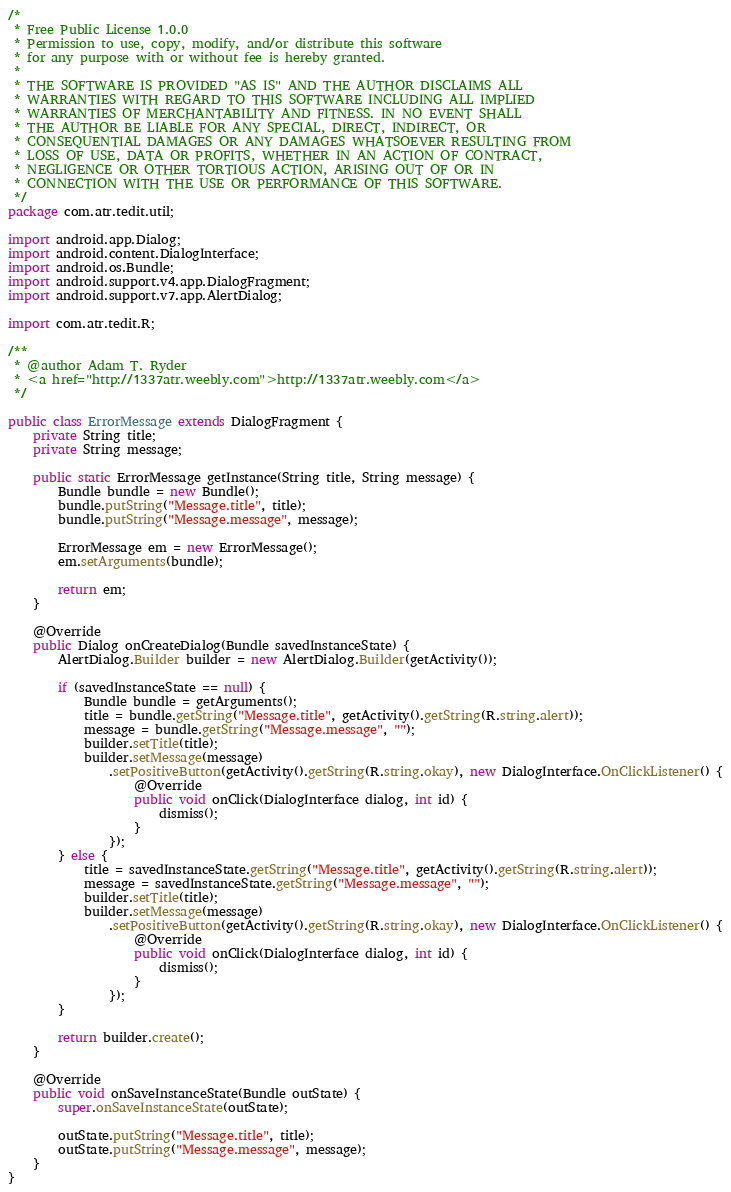Convert code to text. <code><loc_0><loc_0><loc_500><loc_500><_Java_>/*
 * Free Public License 1.0.0
 * Permission to use, copy, modify, and/or distribute this software
 * for any purpose with or without fee is hereby granted.
 *
 * THE SOFTWARE IS PROVIDED "AS IS" AND THE AUTHOR DISCLAIMS ALL
 * WARRANTIES WITH REGARD TO THIS SOFTWARE INCLUDING ALL IMPLIED
 * WARRANTIES OF MERCHANTABILITY AND FITNESS. IN NO EVENT SHALL
 * THE AUTHOR BE LIABLE FOR ANY SPECIAL, DIRECT, INDIRECT, OR
 * CONSEQUENTIAL DAMAGES OR ANY DAMAGES WHATSOEVER RESULTING FROM
 * LOSS OF USE, DATA OR PROFITS, WHETHER IN AN ACTION OF CONTRACT,
 * NEGLIGENCE OR OTHER TORTIOUS ACTION, ARISING OUT OF OR IN
 * CONNECTION WITH THE USE OR PERFORMANCE OF THIS SOFTWARE.
 */
package com.atr.tedit.util;

import android.app.Dialog;
import android.content.DialogInterface;
import android.os.Bundle;
import android.support.v4.app.DialogFragment;
import android.support.v7.app.AlertDialog;

import com.atr.tedit.R;

/**
 * @author Adam T. Ryder
 * <a href="http://1337atr.weebly.com">http://1337atr.weebly.com</a>
 */

public class ErrorMessage extends DialogFragment {
    private String title;
    private String message;

    public static ErrorMessage getInstance(String title, String message) {
        Bundle bundle = new Bundle();
        bundle.putString("Message.title", title);
        bundle.putString("Message.message", message);

        ErrorMessage em = new ErrorMessage();
        em.setArguments(bundle);

        return em;
    }

    @Override
    public Dialog onCreateDialog(Bundle savedInstanceState) {
        AlertDialog.Builder builder = new AlertDialog.Builder(getActivity());

        if (savedInstanceState == null) {
            Bundle bundle = getArguments();
            title = bundle.getString("Message.title", getActivity().getString(R.string.alert));
            message = bundle.getString("Message.message", "");
            builder.setTitle(title);
            builder.setMessage(message)
                .setPositiveButton(getActivity().getString(R.string.okay), new DialogInterface.OnClickListener() {
                    @Override
                    public void onClick(DialogInterface dialog, int id) {
                        dismiss();
                    }
                });
        } else {
            title = savedInstanceState.getString("Message.title", getActivity().getString(R.string.alert));
            message = savedInstanceState.getString("Message.message", "");
            builder.setTitle(title);
            builder.setMessage(message)
                .setPositiveButton(getActivity().getString(R.string.okay), new DialogInterface.OnClickListener() {
                    @Override
                    public void onClick(DialogInterface dialog, int id) {
                        dismiss();
                    }
                });
        }

        return builder.create();
    }

    @Override
    public void onSaveInstanceState(Bundle outState) {
        super.onSaveInstanceState(outState);

        outState.putString("Message.title", title);
        outState.putString("Message.message", message);
    }
}
</code> 